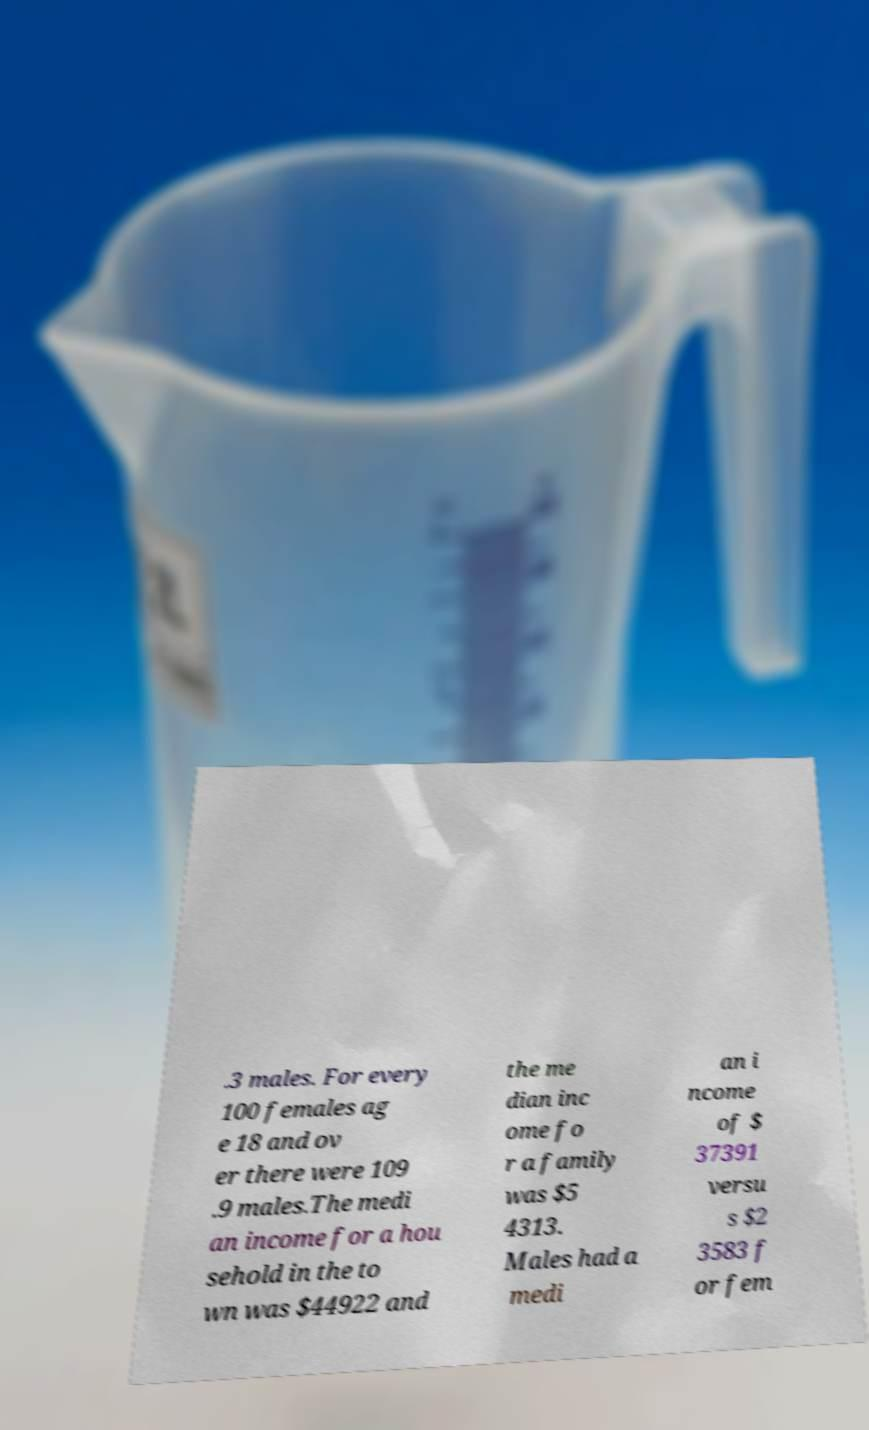What messages or text are displayed in this image? I need them in a readable, typed format. .3 males. For every 100 females ag e 18 and ov er there were 109 .9 males.The medi an income for a hou sehold in the to wn was $44922 and the me dian inc ome fo r a family was $5 4313. Males had a medi an i ncome of $ 37391 versu s $2 3583 f or fem 